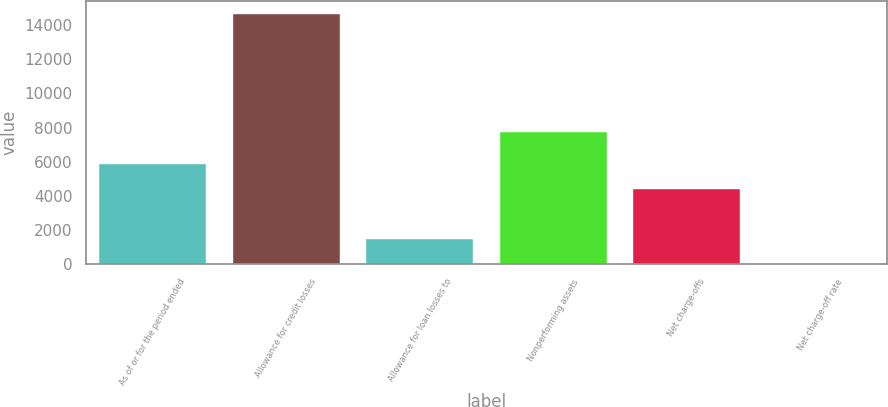Convert chart. <chart><loc_0><loc_0><loc_500><loc_500><bar_chart><fcel>As of or for the period ended<fcel>Allowance for credit losses<fcel>Allowance for loan losses to<fcel>Nonperforming assets<fcel>Net charge-offs<fcel>Net charge-off rate<nl><fcel>5863.53<fcel>14658<fcel>1466.31<fcel>7714<fcel>4397.79<fcel>0.57<nl></chart> 